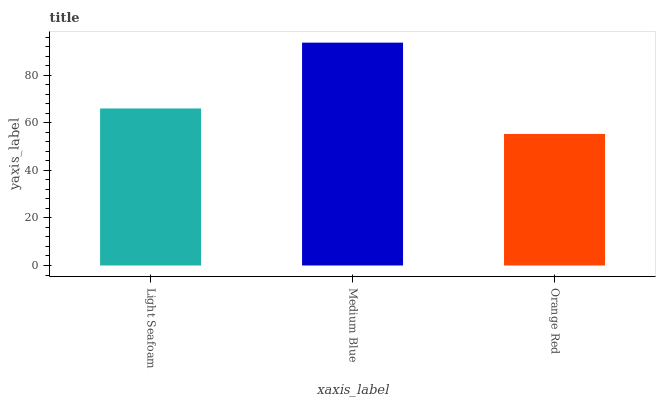Is Orange Red the minimum?
Answer yes or no. Yes. Is Medium Blue the maximum?
Answer yes or no. Yes. Is Medium Blue the minimum?
Answer yes or no. No. Is Orange Red the maximum?
Answer yes or no. No. Is Medium Blue greater than Orange Red?
Answer yes or no. Yes. Is Orange Red less than Medium Blue?
Answer yes or no. Yes. Is Orange Red greater than Medium Blue?
Answer yes or no. No. Is Medium Blue less than Orange Red?
Answer yes or no. No. Is Light Seafoam the high median?
Answer yes or no. Yes. Is Light Seafoam the low median?
Answer yes or no. Yes. Is Orange Red the high median?
Answer yes or no. No. Is Medium Blue the low median?
Answer yes or no. No. 